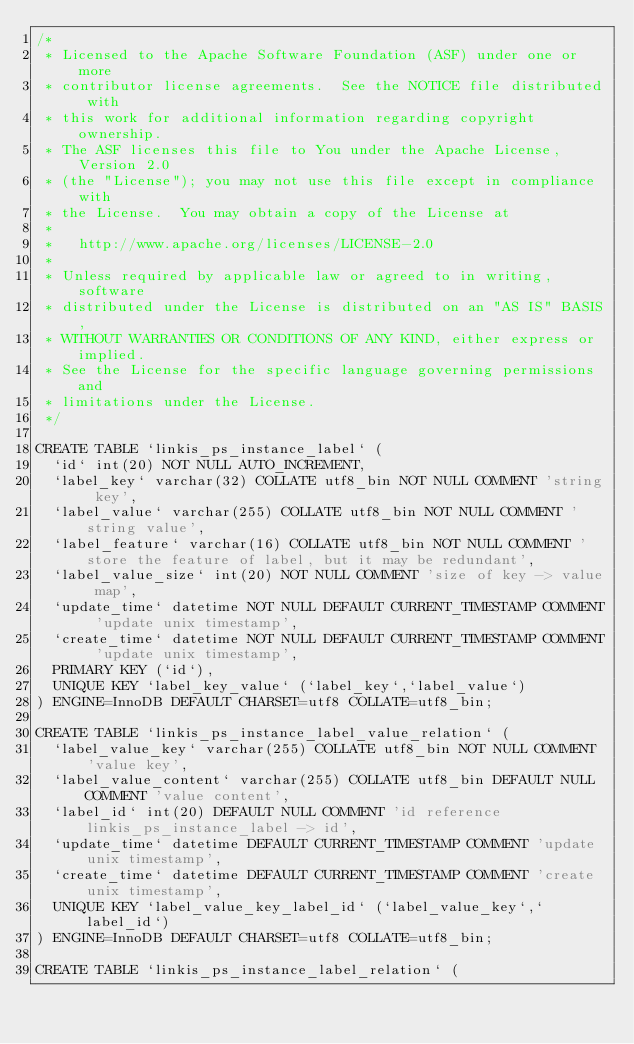Convert code to text. <code><loc_0><loc_0><loc_500><loc_500><_SQL_>/*
 * Licensed to the Apache Software Foundation (ASF) under one or more
 * contributor license agreements.  See the NOTICE file distributed with
 * this work for additional information regarding copyright ownership.
 * The ASF licenses this file to You under the Apache License, Version 2.0
 * (the "License"); you may not use this file except in compliance with
 * the License.  You may obtain a copy of the License at
 * 
 *   http://www.apache.org/licenses/LICENSE-2.0
 * 
 * Unless required by applicable law or agreed to in writing, software
 * distributed under the License is distributed on an "AS IS" BASIS,
 * WITHOUT WARRANTIES OR CONDITIONS OF ANY KIND, either express or implied.
 * See the License for the specific language governing permissions and
 * limitations under the License.
 */
 
CREATE TABLE `linkis_ps_instance_label` (
  `id` int(20) NOT NULL AUTO_INCREMENT,
  `label_key` varchar(32) COLLATE utf8_bin NOT NULL COMMENT 'string key',
  `label_value` varchar(255) COLLATE utf8_bin NOT NULL COMMENT 'string value',
  `label_feature` varchar(16) COLLATE utf8_bin NOT NULL COMMENT 'store the feature of label, but it may be redundant',
  `label_value_size` int(20) NOT NULL COMMENT 'size of key -> value map',
  `update_time` datetime NOT NULL DEFAULT CURRENT_TIMESTAMP COMMENT 'update unix timestamp',
  `create_time` datetime NOT NULL DEFAULT CURRENT_TIMESTAMP COMMENT 'update unix timestamp',
  PRIMARY KEY (`id`),
  UNIQUE KEY `label_key_value` (`label_key`,`label_value`)
) ENGINE=InnoDB DEFAULT CHARSET=utf8 COLLATE=utf8_bin;

CREATE TABLE `linkis_ps_instance_label_value_relation` (
  `label_value_key` varchar(255) COLLATE utf8_bin NOT NULL COMMENT 'value key',
  `label_value_content` varchar(255) COLLATE utf8_bin DEFAULT NULL COMMENT 'value content',
  `label_id` int(20) DEFAULT NULL COMMENT 'id reference linkis_ps_instance_label -> id',
  `update_time` datetime DEFAULT CURRENT_TIMESTAMP COMMENT 'update unix timestamp',
  `create_time` datetime DEFAULT CURRENT_TIMESTAMP COMMENT 'create unix timestamp',
  UNIQUE KEY `label_value_key_label_id` (`label_value_key`,`label_id`)
) ENGINE=InnoDB DEFAULT CHARSET=utf8 COLLATE=utf8_bin;

CREATE TABLE `linkis_ps_instance_label_relation` (</code> 